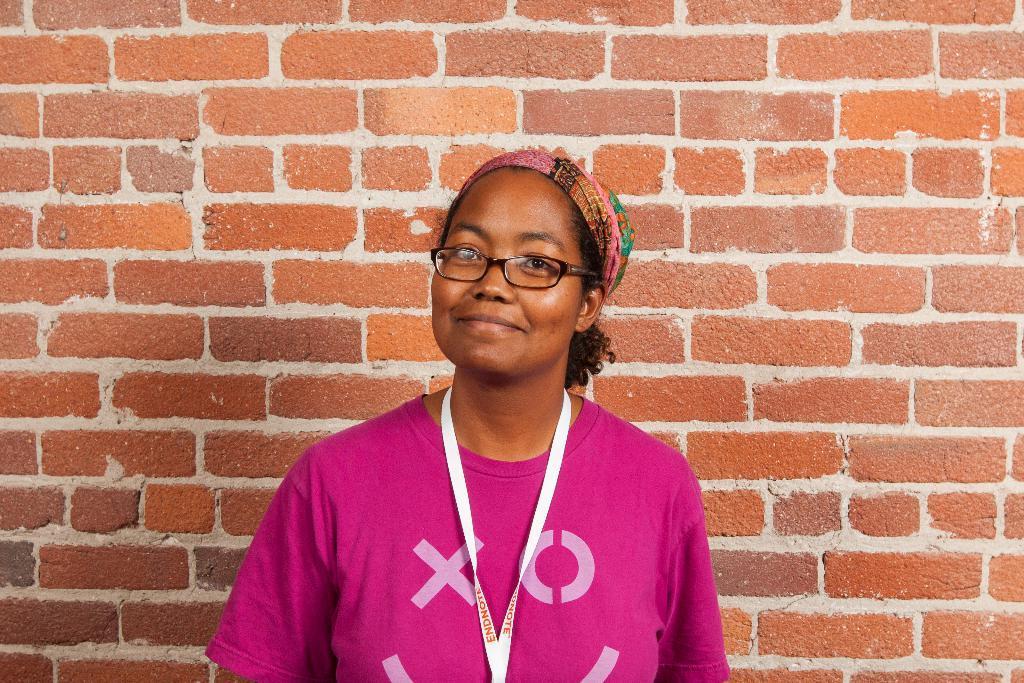How would you summarize this image in a sentence or two? In this image in front there is a person having a smile on her face. Behind her there is a brick wall. 